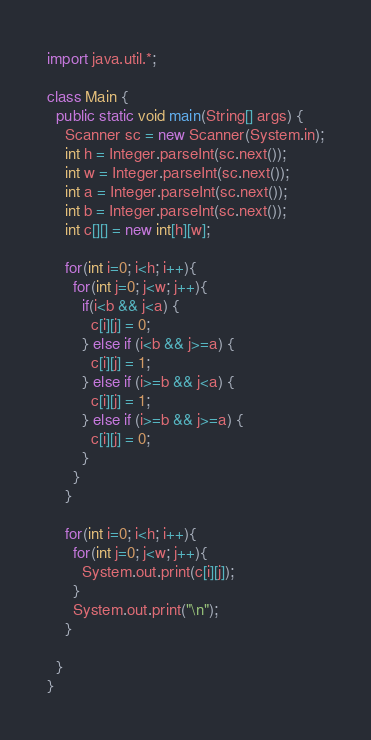Convert code to text. <code><loc_0><loc_0><loc_500><loc_500><_Java_>import java.util.*;

class Main {
  public static void main(String[] args) {
    Scanner sc = new Scanner(System.in);
    int h = Integer.parseInt(sc.next());
    int w = Integer.parseInt(sc.next());
    int a = Integer.parseInt(sc.next());
    int b = Integer.parseInt(sc.next());
    int c[][] = new int[h][w];
    
    for(int i=0; i<h; i++){
      for(int j=0; j<w; j++){
        if(i<b && j<a) {
          c[i][j] = 0;
        } else if (i<b && j>=a) {
          c[i][j] = 1;
        } else if (i>=b && j<a) {
          c[i][j] = 1;
        } else if (i>=b && j>=a) {
          c[i][j] = 0;
        }
      }
    }
    
    for(int i=0; i<h; i++){
      for(int j=0; j<w; j++){
        System.out.print(c[i][j]);
      }
      System.out.print("\n");
    }
    
  }
}
</code> 